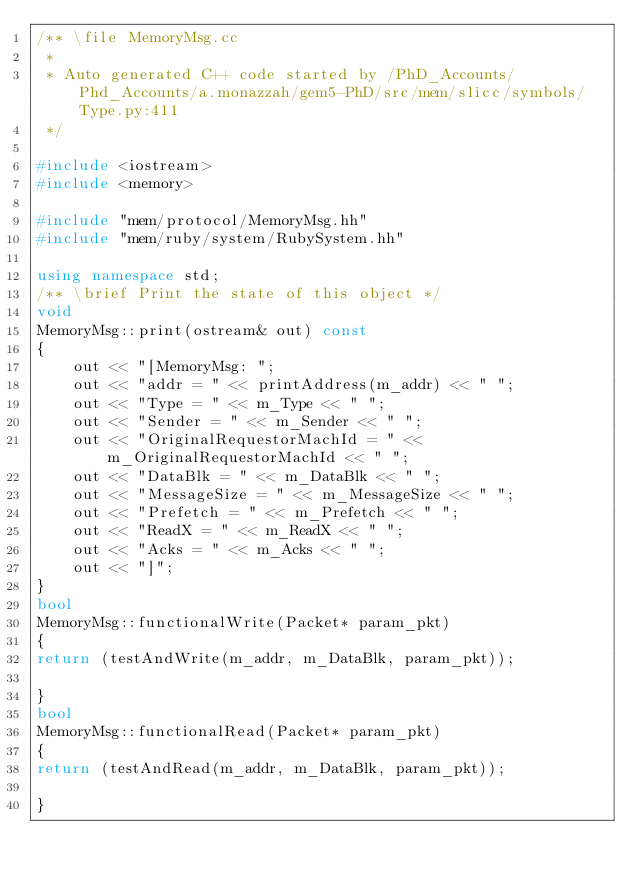<code> <loc_0><loc_0><loc_500><loc_500><_C++_>/** \file MemoryMsg.cc
 *
 * Auto generated C++ code started by /PhD_Accounts/Phd_Accounts/a.monazzah/gem5-PhD/src/mem/slicc/symbols/Type.py:411
 */

#include <iostream>
#include <memory>

#include "mem/protocol/MemoryMsg.hh"
#include "mem/ruby/system/RubySystem.hh"

using namespace std;
/** \brief Print the state of this object */
void
MemoryMsg::print(ostream& out) const
{
    out << "[MemoryMsg: ";
    out << "addr = " << printAddress(m_addr) << " ";
    out << "Type = " << m_Type << " ";
    out << "Sender = " << m_Sender << " ";
    out << "OriginalRequestorMachId = " << m_OriginalRequestorMachId << " ";
    out << "DataBlk = " << m_DataBlk << " ";
    out << "MessageSize = " << m_MessageSize << " ";
    out << "Prefetch = " << m_Prefetch << " ";
    out << "ReadX = " << m_ReadX << " ";
    out << "Acks = " << m_Acks << " ";
    out << "]";
}
bool
MemoryMsg::functionalWrite(Packet* param_pkt)
{
return (testAndWrite(m_addr, m_DataBlk, param_pkt));

}
bool
MemoryMsg::functionalRead(Packet* param_pkt)
{
return (testAndRead(m_addr, m_DataBlk, param_pkt));

}
</code> 